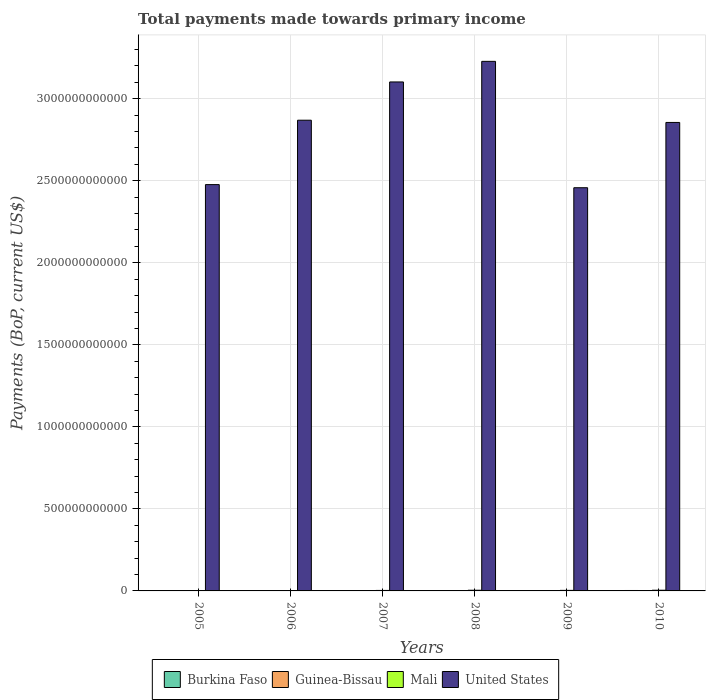How many different coloured bars are there?
Your answer should be very brief. 4. Are the number of bars per tick equal to the number of legend labels?
Ensure brevity in your answer.  Yes. What is the label of the 5th group of bars from the left?
Your answer should be very brief. 2009. What is the total payments made towards primary income in Mali in 2008?
Ensure brevity in your answer.  4.17e+09. Across all years, what is the maximum total payments made towards primary income in United States?
Keep it short and to the point. 3.23e+12. Across all years, what is the minimum total payments made towards primary income in Burkina Faso?
Keep it short and to the point. 1.45e+09. In which year was the total payments made towards primary income in United States maximum?
Ensure brevity in your answer.  2008. What is the total total payments made towards primary income in Guinea-Bissau in the graph?
Make the answer very short. 1.50e+09. What is the difference between the total payments made towards primary income in United States in 2006 and that in 2009?
Offer a very short reply. 4.11e+11. What is the difference between the total payments made towards primary income in United States in 2008 and the total payments made towards primary income in Burkina Faso in 2005?
Provide a succinct answer. 3.23e+12. What is the average total payments made towards primary income in United States per year?
Ensure brevity in your answer.  2.83e+12. In the year 2010, what is the difference between the total payments made towards primary income in United States and total payments made towards primary income in Mali?
Ensure brevity in your answer.  2.85e+12. What is the ratio of the total payments made towards primary income in Mali in 2006 to that in 2010?
Provide a succinct answer. 0.58. Is the total payments made towards primary income in Guinea-Bissau in 2006 less than that in 2009?
Provide a short and direct response. Yes. What is the difference between the highest and the second highest total payments made towards primary income in Guinea-Bissau?
Your response must be concise. 5.70e+06. What is the difference between the highest and the lowest total payments made towards primary income in Burkina Faso?
Keep it short and to the point. 1.20e+09. In how many years, is the total payments made towards primary income in United States greater than the average total payments made towards primary income in United States taken over all years?
Offer a terse response. 4. Is the sum of the total payments made towards primary income in Guinea-Bissau in 2008 and 2009 greater than the maximum total payments made towards primary income in Mali across all years?
Provide a succinct answer. No. Is it the case that in every year, the sum of the total payments made towards primary income in Mali and total payments made towards primary income in United States is greater than the sum of total payments made towards primary income in Guinea-Bissau and total payments made towards primary income in Burkina Faso?
Provide a short and direct response. Yes. What does the 3rd bar from the right in 2009 represents?
Provide a short and direct response. Guinea-Bissau. Is it the case that in every year, the sum of the total payments made towards primary income in Guinea-Bissau and total payments made towards primary income in Burkina Faso is greater than the total payments made towards primary income in Mali?
Make the answer very short. No. Are all the bars in the graph horizontal?
Offer a very short reply. No. What is the difference between two consecutive major ticks on the Y-axis?
Your response must be concise. 5.00e+11. Does the graph contain any zero values?
Your answer should be compact. No. Does the graph contain grids?
Provide a short and direct response. Yes. Where does the legend appear in the graph?
Your answer should be very brief. Bottom center. What is the title of the graph?
Make the answer very short. Total payments made towards primary income. What is the label or title of the Y-axis?
Offer a terse response. Payments (BoP, current US$). What is the Payments (BoP, current US$) of Burkina Faso in 2005?
Your answer should be very brief. 1.45e+09. What is the Payments (BoP, current US$) in Guinea-Bissau in 2005?
Your response must be concise. 1.57e+08. What is the Payments (BoP, current US$) of Mali in 2005?
Provide a short and direct response. 2.11e+09. What is the Payments (BoP, current US$) in United States in 2005?
Ensure brevity in your answer.  2.48e+12. What is the Payments (BoP, current US$) in Burkina Faso in 2006?
Keep it short and to the point. 1.51e+09. What is the Payments (BoP, current US$) of Guinea-Bissau in 2006?
Make the answer very short. 1.76e+08. What is the Payments (BoP, current US$) of Mali in 2006?
Make the answer very short. 2.48e+09. What is the Payments (BoP, current US$) in United States in 2006?
Provide a short and direct response. 2.87e+12. What is the Payments (BoP, current US$) in Burkina Faso in 2007?
Offer a very short reply. 1.77e+09. What is the Payments (BoP, current US$) of Guinea-Bissau in 2007?
Your response must be concise. 2.46e+08. What is the Payments (BoP, current US$) of Mali in 2007?
Provide a short and direct response. 2.99e+09. What is the Payments (BoP, current US$) in United States in 2007?
Give a very brief answer. 3.10e+12. What is the Payments (BoP, current US$) in Burkina Faso in 2008?
Your response must be concise. 2.44e+09. What is the Payments (BoP, current US$) in Guinea-Bissau in 2008?
Your answer should be very brief. 2.99e+08. What is the Payments (BoP, current US$) in Mali in 2008?
Offer a very short reply. 4.17e+09. What is the Payments (BoP, current US$) in United States in 2008?
Give a very brief answer. 3.23e+12. What is the Payments (BoP, current US$) of Burkina Faso in 2009?
Keep it short and to the point. 2.03e+09. What is the Payments (BoP, current US$) of Guinea-Bissau in 2009?
Ensure brevity in your answer.  3.09e+08. What is the Payments (BoP, current US$) of Mali in 2009?
Provide a short and direct response. 3.35e+09. What is the Payments (BoP, current US$) of United States in 2009?
Keep it short and to the point. 2.46e+12. What is the Payments (BoP, current US$) in Burkina Faso in 2010?
Provide a succinct answer. 2.65e+09. What is the Payments (BoP, current US$) in Guinea-Bissau in 2010?
Provide a short and direct response. 3.15e+08. What is the Payments (BoP, current US$) in Mali in 2010?
Offer a very short reply. 4.24e+09. What is the Payments (BoP, current US$) in United States in 2010?
Make the answer very short. 2.86e+12. Across all years, what is the maximum Payments (BoP, current US$) in Burkina Faso?
Offer a terse response. 2.65e+09. Across all years, what is the maximum Payments (BoP, current US$) of Guinea-Bissau?
Provide a short and direct response. 3.15e+08. Across all years, what is the maximum Payments (BoP, current US$) of Mali?
Your answer should be compact. 4.24e+09. Across all years, what is the maximum Payments (BoP, current US$) of United States?
Your answer should be compact. 3.23e+12. Across all years, what is the minimum Payments (BoP, current US$) in Burkina Faso?
Offer a very short reply. 1.45e+09. Across all years, what is the minimum Payments (BoP, current US$) in Guinea-Bissau?
Keep it short and to the point. 1.57e+08. Across all years, what is the minimum Payments (BoP, current US$) of Mali?
Your answer should be compact. 2.11e+09. Across all years, what is the minimum Payments (BoP, current US$) in United States?
Keep it short and to the point. 2.46e+12. What is the total Payments (BoP, current US$) of Burkina Faso in the graph?
Ensure brevity in your answer.  1.19e+1. What is the total Payments (BoP, current US$) in Guinea-Bissau in the graph?
Provide a succinct answer. 1.50e+09. What is the total Payments (BoP, current US$) in Mali in the graph?
Your response must be concise. 1.93e+1. What is the total Payments (BoP, current US$) of United States in the graph?
Offer a very short reply. 1.70e+13. What is the difference between the Payments (BoP, current US$) in Burkina Faso in 2005 and that in 2006?
Provide a short and direct response. -5.92e+07. What is the difference between the Payments (BoP, current US$) of Guinea-Bissau in 2005 and that in 2006?
Ensure brevity in your answer.  -1.88e+07. What is the difference between the Payments (BoP, current US$) in Mali in 2005 and that in 2006?
Make the answer very short. -3.68e+08. What is the difference between the Payments (BoP, current US$) of United States in 2005 and that in 2006?
Provide a succinct answer. -3.92e+11. What is the difference between the Payments (BoP, current US$) of Burkina Faso in 2005 and that in 2007?
Offer a terse response. -3.15e+08. What is the difference between the Payments (BoP, current US$) of Guinea-Bissau in 2005 and that in 2007?
Give a very brief answer. -8.96e+07. What is the difference between the Payments (BoP, current US$) in Mali in 2005 and that in 2007?
Offer a terse response. -8.77e+08. What is the difference between the Payments (BoP, current US$) in United States in 2005 and that in 2007?
Provide a succinct answer. -6.26e+11. What is the difference between the Payments (BoP, current US$) in Burkina Faso in 2005 and that in 2008?
Offer a terse response. -9.89e+08. What is the difference between the Payments (BoP, current US$) of Guinea-Bissau in 2005 and that in 2008?
Provide a short and direct response. -1.42e+08. What is the difference between the Payments (BoP, current US$) in Mali in 2005 and that in 2008?
Your answer should be very brief. -2.06e+09. What is the difference between the Payments (BoP, current US$) of United States in 2005 and that in 2008?
Your answer should be compact. -7.51e+11. What is the difference between the Payments (BoP, current US$) in Burkina Faso in 2005 and that in 2009?
Keep it short and to the point. -5.82e+08. What is the difference between the Payments (BoP, current US$) in Guinea-Bissau in 2005 and that in 2009?
Provide a short and direct response. -1.52e+08. What is the difference between the Payments (BoP, current US$) of Mali in 2005 and that in 2009?
Give a very brief answer. -1.24e+09. What is the difference between the Payments (BoP, current US$) of United States in 2005 and that in 2009?
Ensure brevity in your answer.  1.90e+1. What is the difference between the Payments (BoP, current US$) in Burkina Faso in 2005 and that in 2010?
Make the answer very short. -1.20e+09. What is the difference between the Payments (BoP, current US$) in Guinea-Bissau in 2005 and that in 2010?
Keep it short and to the point. -1.58e+08. What is the difference between the Payments (BoP, current US$) of Mali in 2005 and that in 2010?
Provide a short and direct response. -2.13e+09. What is the difference between the Payments (BoP, current US$) in United States in 2005 and that in 2010?
Offer a terse response. -3.79e+11. What is the difference between the Payments (BoP, current US$) of Burkina Faso in 2006 and that in 2007?
Give a very brief answer. -2.56e+08. What is the difference between the Payments (BoP, current US$) of Guinea-Bissau in 2006 and that in 2007?
Keep it short and to the point. -7.07e+07. What is the difference between the Payments (BoP, current US$) of Mali in 2006 and that in 2007?
Offer a terse response. -5.09e+08. What is the difference between the Payments (BoP, current US$) of United States in 2006 and that in 2007?
Provide a succinct answer. -2.33e+11. What is the difference between the Payments (BoP, current US$) of Burkina Faso in 2006 and that in 2008?
Ensure brevity in your answer.  -9.30e+08. What is the difference between the Payments (BoP, current US$) in Guinea-Bissau in 2006 and that in 2008?
Provide a succinct answer. -1.23e+08. What is the difference between the Payments (BoP, current US$) in Mali in 2006 and that in 2008?
Your answer should be very brief. -1.70e+09. What is the difference between the Payments (BoP, current US$) of United States in 2006 and that in 2008?
Provide a short and direct response. -3.59e+11. What is the difference between the Payments (BoP, current US$) of Burkina Faso in 2006 and that in 2009?
Provide a succinct answer. -5.23e+08. What is the difference between the Payments (BoP, current US$) in Guinea-Bissau in 2006 and that in 2009?
Provide a succinct answer. -1.33e+08. What is the difference between the Payments (BoP, current US$) in Mali in 2006 and that in 2009?
Provide a short and direct response. -8.75e+08. What is the difference between the Payments (BoP, current US$) of United States in 2006 and that in 2009?
Your response must be concise. 4.11e+11. What is the difference between the Payments (BoP, current US$) of Burkina Faso in 2006 and that in 2010?
Offer a very short reply. -1.14e+09. What is the difference between the Payments (BoP, current US$) in Guinea-Bissau in 2006 and that in 2010?
Provide a short and direct response. -1.39e+08. What is the difference between the Payments (BoP, current US$) of Mali in 2006 and that in 2010?
Offer a very short reply. -1.76e+09. What is the difference between the Payments (BoP, current US$) in United States in 2006 and that in 2010?
Offer a very short reply. 1.36e+1. What is the difference between the Payments (BoP, current US$) of Burkina Faso in 2007 and that in 2008?
Make the answer very short. -6.74e+08. What is the difference between the Payments (BoP, current US$) of Guinea-Bissau in 2007 and that in 2008?
Your response must be concise. -5.24e+07. What is the difference between the Payments (BoP, current US$) in Mali in 2007 and that in 2008?
Your answer should be very brief. -1.19e+09. What is the difference between the Payments (BoP, current US$) in United States in 2007 and that in 2008?
Provide a short and direct response. -1.26e+11. What is the difference between the Payments (BoP, current US$) of Burkina Faso in 2007 and that in 2009?
Your answer should be very brief. -2.68e+08. What is the difference between the Payments (BoP, current US$) in Guinea-Bissau in 2007 and that in 2009?
Give a very brief answer. -6.25e+07. What is the difference between the Payments (BoP, current US$) of Mali in 2007 and that in 2009?
Your answer should be compact. -3.65e+08. What is the difference between the Payments (BoP, current US$) in United States in 2007 and that in 2009?
Ensure brevity in your answer.  6.45e+11. What is the difference between the Payments (BoP, current US$) of Burkina Faso in 2007 and that in 2010?
Make the answer very short. -8.88e+08. What is the difference between the Payments (BoP, current US$) of Guinea-Bissau in 2007 and that in 2010?
Make the answer very short. -6.82e+07. What is the difference between the Payments (BoP, current US$) in Mali in 2007 and that in 2010?
Your response must be concise. -1.25e+09. What is the difference between the Payments (BoP, current US$) of United States in 2007 and that in 2010?
Provide a succinct answer. 2.47e+11. What is the difference between the Payments (BoP, current US$) of Burkina Faso in 2008 and that in 2009?
Make the answer very short. 4.07e+08. What is the difference between the Payments (BoP, current US$) in Guinea-Bissau in 2008 and that in 2009?
Make the answer very short. -1.01e+07. What is the difference between the Payments (BoP, current US$) in Mali in 2008 and that in 2009?
Offer a very short reply. 8.21e+08. What is the difference between the Payments (BoP, current US$) in United States in 2008 and that in 2009?
Your answer should be very brief. 7.70e+11. What is the difference between the Payments (BoP, current US$) in Burkina Faso in 2008 and that in 2010?
Provide a short and direct response. -2.13e+08. What is the difference between the Payments (BoP, current US$) of Guinea-Bissau in 2008 and that in 2010?
Your response must be concise. -1.58e+07. What is the difference between the Payments (BoP, current US$) of Mali in 2008 and that in 2010?
Your answer should be compact. -6.41e+07. What is the difference between the Payments (BoP, current US$) of United States in 2008 and that in 2010?
Offer a terse response. 3.72e+11. What is the difference between the Payments (BoP, current US$) of Burkina Faso in 2009 and that in 2010?
Keep it short and to the point. -6.20e+08. What is the difference between the Payments (BoP, current US$) of Guinea-Bissau in 2009 and that in 2010?
Your answer should be very brief. -5.70e+06. What is the difference between the Payments (BoP, current US$) in Mali in 2009 and that in 2010?
Offer a very short reply. -8.85e+08. What is the difference between the Payments (BoP, current US$) of United States in 2009 and that in 2010?
Provide a succinct answer. -3.98e+11. What is the difference between the Payments (BoP, current US$) in Burkina Faso in 2005 and the Payments (BoP, current US$) in Guinea-Bissau in 2006?
Make the answer very short. 1.28e+09. What is the difference between the Payments (BoP, current US$) of Burkina Faso in 2005 and the Payments (BoP, current US$) of Mali in 2006?
Ensure brevity in your answer.  -1.02e+09. What is the difference between the Payments (BoP, current US$) in Burkina Faso in 2005 and the Payments (BoP, current US$) in United States in 2006?
Offer a terse response. -2.87e+12. What is the difference between the Payments (BoP, current US$) in Guinea-Bissau in 2005 and the Payments (BoP, current US$) in Mali in 2006?
Offer a terse response. -2.32e+09. What is the difference between the Payments (BoP, current US$) of Guinea-Bissau in 2005 and the Payments (BoP, current US$) of United States in 2006?
Make the answer very short. -2.87e+12. What is the difference between the Payments (BoP, current US$) in Mali in 2005 and the Payments (BoP, current US$) in United States in 2006?
Give a very brief answer. -2.87e+12. What is the difference between the Payments (BoP, current US$) in Burkina Faso in 2005 and the Payments (BoP, current US$) in Guinea-Bissau in 2007?
Provide a short and direct response. 1.21e+09. What is the difference between the Payments (BoP, current US$) of Burkina Faso in 2005 and the Payments (BoP, current US$) of Mali in 2007?
Your answer should be very brief. -1.53e+09. What is the difference between the Payments (BoP, current US$) in Burkina Faso in 2005 and the Payments (BoP, current US$) in United States in 2007?
Provide a succinct answer. -3.10e+12. What is the difference between the Payments (BoP, current US$) of Guinea-Bissau in 2005 and the Payments (BoP, current US$) of Mali in 2007?
Provide a short and direct response. -2.83e+09. What is the difference between the Payments (BoP, current US$) of Guinea-Bissau in 2005 and the Payments (BoP, current US$) of United States in 2007?
Provide a succinct answer. -3.10e+12. What is the difference between the Payments (BoP, current US$) of Mali in 2005 and the Payments (BoP, current US$) of United States in 2007?
Make the answer very short. -3.10e+12. What is the difference between the Payments (BoP, current US$) in Burkina Faso in 2005 and the Payments (BoP, current US$) in Guinea-Bissau in 2008?
Give a very brief answer. 1.15e+09. What is the difference between the Payments (BoP, current US$) of Burkina Faso in 2005 and the Payments (BoP, current US$) of Mali in 2008?
Your answer should be very brief. -2.72e+09. What is the difference between the Payments (BoP, current US$) in Burkina Faso in 2005 and the Payments (BoP, current US$) in United States in 2008?
Your response must be concise. -3.23e+12. What is the difference between the Payments (BoP, current US$) in Guinea-Bissau in 2005 and the Payments (BoP, current US$) in Mali in 2008?
Keep it short and to the point. -4.01e+09. What is the difference between the Payments (BoP, current US$) in Guinea-Bissau in 2005 and the Payments (BoP, current US$) in United States in 2008?
Ensure brevity in your answer.  -3.23e+12. What is the difference between the Payments (BoP, current US$) in Mali in 2005 and the Payments (BoP, current US$) in United States in 2008?
Make the answer very short. -3.23e+12. What is the difference between the Payments (BoP, current US$) in Burkina Faso in 2005 and the Payments (BoP, current US$) in Guinea-Bissau in 2009?
Your answer should be compact. 1.14e+09. What is the difference between the Payments (BoP, current US$) of Burkina Faso in 2005 and the Payments (BoP, current US$) of Mali in 2009?
Ensure brevity in your answer.  -1.90e+09. What is the difference between the Payments (BoP, current US$) in Burkina Faso in 2005 and the Payments (BoP, current US$) in United States in 2009?
Offer a very short reply. -2.46e+12. What is the difference between the Payments (BoP, current US$) of Guinea-Bissau in 2005 and the Payments (BoP, current US$) of Mali in 2009?
Provide a succinct answer. -3.19e+09. What is the difference between the Payments (BoP, current US$) of Guinea-Bissau in 2005 and the Payments (BoP, current US$) of United States in 2009?
Your answer should be very brief. -2.46e+12. What is the difference between the Payments (BoP, current US$) in Mali in 2005 and the Payments (BoP, current US$) in United States in 2009?
Make the answer very short. -2.46e+12. What is the difference between the Payments (BoP, current US$) in Burkina Faso in 2005 and the Payments (BoP, current US$) in Guinea-Bissau in 2010?
Keep it short and to the point. 1.14e+09. What is the difference between the Payments (BoP, current US$) in Burkina Faso in 2005 and the Payments (BoP, current US$) in Mali in 2010?
Your answer should be very brief. -2.78e+09. What is the difference between the Payments (BoP, current US$) of Burkina Faso in 2005 and the Payments (BoP, current US$) of United States in 2010?
Offer a very short reply. -2.85e+12. What is the difference between the Payments (BoP, current US$) in Guinea-Bissau in 2005 and the Payments (BoP, current US$) in Mali in 2010?
Give a very brief answer. -4.08e+09. What is the difference between the Payments (BoP, current US$) of Guinea-Bissau in 2005 and the Payments (BoP, current US$) of United States in 2010?
Your answer should be very brief. -2.86e+12. What is the difference between the Payments (BoP, current US$) in Mali in 2005 and the Payments (BoP, current US$) in United States in 2010?
Make the answer very short. -2.85e+12. What is the difference between the Payments (BoP, current US$) of Burkina Faso in 2006 and the Payments (BoP, current US$) of Guinea-Bissau in 2007?
Your answer should be very brief. 1.26e+09. What is the difference between the Payments (BoP, current US$) in Burkina Faso in 2006 and the Payments (BoP, current US$) in Mali in 2007?
Provide a succinct answer. -1.47e+09. What is the difference between the Payments (BoP, current US$) in Burkina Faso in 2006 and the Payments (BoP, current US$) in United States in 2007?
Keep it short and to the point. -3.10e+12. What is the difference between the Payments (BoP, current US$) of Guinea-Bissau in 2006 and the Payments (BoP, current US$) of Mali in 2007?
Provide a short and direct response. -2.81e+09. What is the difference between the Payments (BoP, current US$) in Guinea-Bissau in 2006 and the Payments (BoP, current US$) in United States in 2007?
Your response must be concise. -3.10e+12. What is the difference between the Payments (BoP, current US$) in Mali in 2006 and the Payments (BoP, current US$) in United States in 2007?
Make the answer very short. -3.10e+12. What is the difference between the Payments (BoP, current US$) in Burkina Faso in 2006 and the Payments (BoP, current US$) in Guinea-Bissau in 2008?
Give a very brief answer. 1.21e+09. What is the difference between the Payments (BoP, current US$) in Burkina Faso in 2006 and the Payments (BoP, current US$) in Mali in 2008?
Your answer should be very brief. -2.66e+09. What is the difference between the Payments (BoP, current US$) in Burkina Faso in 2006 and the Payments (BoP, current US$) in United States in 2008?
Offer a terse response. -3.23e+12. What is the difference between the Payments (BoP, current US$) of Guinea-Bissau in 2006 and the Payments (BoP, current US$) of Mali in 2008?
Your answer should be very brief. -4.00e+09. What is the difference between the Payments (BoP, current US$) in Guinea-Bissau in 2006 and the Payments (BoP, current US$) in United States in 2008?
Ensure brevity in your answer.  -3.23e+12. What is the difference between the Payments (BoP, current US$) in Mali in 2006 and the Payments (BoP, current US$) in United States in 2008?
Your answer should be compact. -3.23e+12. What is the difference between the Payments (BoP, current US$) of Burkina Faso in 2006 and the Payments (BoP, current US$) of Guinea-Bissau in 2009?
Your answer should be very brief. 1.20e+09. What is the difference between the Payments (BoP, current US$) of Burkina Faso in 2006 and the Payments (BoP, current US$) of Mali in 2009?
Keep it short and to the point. -1.84e+09. What is the difference between the Payments (BoP, current US$) of Burkina Faso in 2006 and the Payments (BoP, current US$) of United States in 2009?
Your answer should be very brief. -2.46e+12. What is the difference between the Payments (BoP, current US$) in Guinea-Bissau in 2006 and the Payments (BoP, current US$) in Mali in 2009?
Provide a short and direct response. -3.18e+09. What is the difference between the Payments (BoP, current US$) of Guinea-Bissau in 2006 and the Payments (BoP, current US$) of United States in 2009?
Keep it short and to the point. -2.46e+12. What is the difference between the Payments (BoP, current US$) in Mali in 2006 and the Payments (BoP, current US$) in United States in 2009?
Offer a terse response. -2.46e+12. What is the difference between the Payments (BoP, current US$) in Burkina Faso in 2006 and the Payments (BoP, current US$) in Guinea-Bissau in 2010?
Give a very brief answer. 1.20e+09. What is the difference between the Payments (BoP, current US$) of Burkina Faso in 2006 and the Payments (BoP, current US$) of Mali in 2010?
Your answer should be compact. -2.72e+09. What is the difference between the Payments (BoP, current US$) in Burkina Faso in 2006 and the Payments (BoP, current US$) in United States in 2010?
Offer a very short reply. -2.85e+12. What is the difference between the Payments (BoP, current US$) in Guinea-Bissau in 2006 and the Payments (BoP, current US$) in Mali in 2010?
Provide a short and direct response. -4.06e+09. What is the difference between the Payments (BoP, current US$) in Guinea-Bissau in 2006 and the Payments (BoP, current US$) in United States in 2010?
Your answer should be compact. -2.86e+12. What is the difference between the Payments (BoP, current US$) in Mali in 2006 and the Payments (BoP, current US$) in United States in 2010?
Give a very brief answer. -2.85e+12. What is the difference between the Payments (BoP, current US$) in Burkina Faso in 2007 and the Payments (BoP, current US$) in Guinea-Bissau in 2008?
Offer a very short reply. 1.47e+09. What is the difference between the Payments (BoP, current US$) in Burkina Faso in 2007 and the Payments (BoP, current US$) in Mali in 2008?
Provide a short and direct response. -2.40e+09. What is the difference between the Payments (BoP, current US$) of Burkina Faso in 2007 and the Payments (BoP, current US$) of United States in 2008?
Offer a very short reply. -3.23e+12. What is the difference between the Payments (BoP, current US$) in Guinea-Bissau in 2007 and the Payments (BoP, current US$) in Mali in 2008?
Give a very brief answer. -3.92e+09. What is the difference between the Payments (BoP, current US$) in Guinea-Bissau in 2007 and the Payments (BoP, current US$) in United States in 2008?
Your response must be concise. -3.23e+12. What is the difference between the Payments (BoP, current US$) in Mali in 2007 and the Payments (BoP, current US$) in United States in 2008?
Ensure brevity in your answer.  -3.22e+12. What is the difference between the Payments (BoP, current US$) in Burkina Faso in 2007 and the Payments (BoP, current US$) in Guinea-Bissau in 2009?
Give a very brief answer. 1.46e+09. What is the difference between the Payments (BoP, current US$) of Burkina Faso in 2007 and the Payments (BoP, current US$) of Mali in 2009?
Provide a succinct answer. -1.58e+09. What is the difference between the Payments (BoP, current US$) in Burkina Faso in 2007 and the Payments (BoP, current US$) in United States in 2009?
Provide a short and direct response. -2.46e+12. What is the difference between the Payments (BoP, current US$) of Guinea-Bissau in 2007 and the Payments (BoP, current US$) of Mali in 2009?
Ensure brevity in your answer.  -3.10e+09. What is the difference between the Payments (BoP, current US$) of Guinea-Bissau in 2007 and the Payments (BoP, current US$) of United States in 2009?
Your answer should be very brief. -2.46e+12. What is the difference between the Payments (BoP, current US$) of Mali in 2007 and the Payments (BoP, current US$) of United States in 2009?
Provide a succinct answer. -2.45e+12. What is the difference between the Payments (BoP, current US$) in Burkina Faso in 2007 and the Payments (BoP, current US$) in Guinea-Bissau in 2010?
Your response must be concise. 1.45e+09. What is the difference between the Payments (BoP, current US$) of Burkina Faso in 2007 and the Payments (BoP, current US$) of Mali in 2010?
Ensure brevity in your answer.  -2.47e+09. What is the difference between the Payments (BoP, current US$) in Burkina Faso in 2007 and the Payments (BoP, current US$) in United States in 2010?
Your response must be concise. -2.85e+12. What is the difference between the Payments (BoP, current US$) of Guinea-Bissau in 2007 and the Payments (BoP, current US$) of Mali in 2010?
Offer a very short reply. -3.99e+09. What is the difference between the Payments (BoP, current US$) of Guinea-Bissau in 2007 and the Payments (BoP, current US$) of United States in 2010?
Your answer should be compact. -2.86e+12. What is the difference between the Payments (BoP, current US$) in Mali in 2007 and the Payments (BoP, current US$) in United States in 2010?
Offer a very short reply. -2.85e+12. What is the difference between the Payments (BoP, current US$) in Burkina Faso in 2008 and the Payments (BoP, current US$) in Guinea-Bissau in 2009?
Your response must be concise. 2.13e+09. What is the difference between the Payments (BoP, current US$) of Burkina Faso in 2008 and the Payments (BoP, current US$) of Mali in 2009?
Offer a terse response. -9.09e+08. What is the difference between the Payments (BoP, current US$) of Burkina Faso in 2008 and the Payments (BoP, current US$) of United States in 2009?
Your answer should be compact. -2.46e+12. What is the difference between the Payments (BoP, current US$) of Guinea-Bissau in 2008 and the Payments (BoP, current US$) of Mali in 2009?
Provide a succinct answer. -3.05e+09. What is the difference between the Payments (BoP, current US$) in Guinea-Bissau in 2008 and the Payments (BoP, current US$) in United States in 2009?
Your answer should be compact. -2.46e+12. What is the difference between the Payments (BoP, current US$) in Mali in 2008 and the Payments (BoP, current US$) in United States in 2009?
Your response must be concise. -2.45e+12. What is the difference between the Payments (BoP, current US$) in Burkina Faso in 2008 and the Payments (BoP, current US$) in Guinea-Bissau in 2010?
Offer a very short reply. 2.13e+09. What is the difference between the Payments (BoP, current US$) in Burkina Faso in 2008 and the Payments (BoP, current US$) in Mali in 2010?
Make the answer very short. -1.79e+09. What is the difference between the Payments (BoP, current US$) of Burkina Faso in 2008 and the Payments (BoP, current US$) of United States in 2010?
Provide a succinct answer. -2.85e+12. What is the difference between the Payments (BoP, current US$) in Guinea-Bissau in 2008 and the Payments (BoP, current US$) in Mali in 2010?
Provide a succinct answer. -3.94e+09. What is the difference between the Payments (BoP, current US$) in Guinea-Bissau in 2008 and the Payments (BoP, current US$) in United States in 2010?
Make the answer very short. -2.86e+12. What is the difference between the Payments (BoP, current US$) in Mali in 2008 and the Payments (BoP, current US$) in United States in 2010?
Your response must be concise. -2.85e+12. What is the difference between the Payments (BoP, current US$) in Burkina Faso in 2009 and the Payments (BoP, current US$) in Guinea-Bissau in 2010?
Offer a very short reply. 1.72e+09. What is the difference between the Payments (BoP, current US$) in Burkina Faso in 2009 and the Payments (BoP, current US$) in Mali in 2010?
Provide a short and direct response. -2.20e+09. What is the difference between the Payments (BoP, current US$) of Burkina Faso in 2009 and the Payments (BoP, current US$) of United States in 2010?
Offer a terse response. -2.85e+12. What is the difference between the Payments (BoP, current US$) in Guinea-Bissau in 2009 and the Payments (BoP, current US$) in Mali in 2010?
Your answer should be compact. -3.93e+09. What is the difference between the Payments (BoP, current US$) in Guinea-Bissau in 2009 and the Payments (BoP, current US$) in United States in 2010?
Make the answer very short. -2.86e+12. What is the difference between the Payments (BoP, current US$) in Mali in 2009 and the Payments (BoP, current US$) in United States in 2010?
Provide a short and direct response. -2.85e+12. What is the average Payments (BoP, current US$) of Burkina Faso per year?
Ensure brevity in your answer.  1.98e+09. What is the average Payments (BoP, current US$) in Guinea-Bissau per year?
Make the answer very short. 2.50e+08. What is the average Payments (BoP, current US$) in Mali per year?
Offer a very short reply. 3.22e+09. What is the average Payments (BoP, current US$) in United States per year?
Make the answer very short. 2.83e+12. In the year 2005, what is the difference between the Payments (BoP, current US$) of Burkina Faso and Payments (BoP, current US$) of Guinea-Bissau?
Your answer should be very brief. 1.30e+09. In the year 2005, what is the difference between the Payments (BoP, current US$) of Burkina Faso and Payments (BoP, current US$) of Mali?
Make the answer very short. -6.56e+08. In the year 2005, what is the difference between the Payments (BoP, current US$) of Burkina Faso and Payments (BoP, current US$) of United States?
Offer a terse response. -2.48e+12. In the year 2005, what is the difference between the Payments (BoP, current US$) of Guinea-Bissau and Payments (BoP, current US$) of Mali?
Provide a succinct answer. -1.95e+09. In the year 2005, what is the difference between the Payments (BoP, current US$) of Guinea-Bissau and Payments (BoP, current US$) of United States?
Provide a succinct answer. -2.48e+12. In the year 2005, what is the difference between the Payments (BoP, current US$) of Mali and Payments (BoP, current US$) of United States?
Offer a terse response. -2.47e+12. In the year 2006, what is the difference between the Payments (BoP, current US$) in Burkina Faso and Payments (BoP, current US$) in Guinea-Bissau?
Make the answer very short. 1.34e+09. In the year 2006, what is the difference between the Payments (BoP, current US$) of Burkina Faso and Payments (BoP, current US$) of Mali?
Your answer should be compact. -9.65e+08. In the year 2006, what is the difference between the Payments (BoP, current US$) of Burkina Faso and Payments (BoP, current US$) of United States?
Ensure brevity in your answer.  -2.87e+12. In the year 2006, what is the difference between the Payments (BoP, current US$) of Guinea-Bissau and Payments (BoP, current US$) of Mali?
Give a very brief answer. -2.30e+09. In the year 2006, what is the difference between the Payments (BoP, current US$) in Guinea-Bissau and Payments (BoP, current US$) in United States?
Your response must be concise. -2.87e+12. In the year 2006, what is the difference between the Payments (BoP, current US$) of Mali and Payments (BoP, current US$) of United States?
Ensure brevity in your answer.  -2.87e+12. In the year 2007, what is the difference between the Payments (BoP, current US$) in Burkina Faso and Payments (BoP, current US$) in Guinea-Bissau?
Give a very brief answer. 1.52e+09. In the year 2007, what is the difference between the Payments (BoP, current US$) of Burkina Faso and Payments (BoP, current US$) of Mali?
Provide a short and direct response. -1.22e+09. In the year 2007, what is the difference between the Payments (BoP, current US$) in Burkina Faso and Payments (BoP, current US$) in United States?
Provide a succinct answer. -3.10e+12. In the year 2007, what is the difference between the Payments (BoP, current US$) in Guinea-Bissau and Payments (BoP, current US$) in Mali?
Keep it short and to the point. -2.74e+09. In the year 2007, what is the difference between the Payments (BoP, current US$) in Guinea-Bissau and Payments (BoP, current US$) in United States?
Offer a terse response. -3.10e+12. In the year 2007, what is the difference between the Payments (BoP, current US$) in Mali and Payments (BoP, current US$) in United States?
Make the answer very short. -3.10e+12. In the year 2008, what is the difference between the Payments (BoP, current US$) in Burkina Faso and Payments (BoP, current US$) in Guinea-Bissau?
Provide a short and direct response. 2.14e+09. In the year 2008, what is the difference between the Payments (BoP, current US$) in Burkina Faso and Payments (BoP, current US$) in Mali?
Provide a succinct answer. -1.73e+09. In the year 2008, what is the difference between the Payments (BoP, current US$) in Burkina Faso and Payments (BoP, current US$) in United States?
Provide a short and direct response. -3.23e+12. In the year 2008, what is the difference between the Payments (BoP, current US$) of Guinea-Bissau and Payments (BoP, current US$) of Mali?
Your answer should be very brief. -3.87e+09. In the year 2008, what is the difference between the Payments (BoP, current US$) of Guinea-Bissau and Payments (BoP, current US$) of United States?
Your response must be concise. -3.23e+12. In the year 2008, what is the difference between the Payments (BoP, current US$) of Mali and Payments (BoP, current US$) of United States?
Your answer should be very brief. -3.22e+12. In the year 2009, what is the difference between the Payments (BoP, current US$) in Burkina Faso and Payments (BoP, current US$) in Guinea-Bissau?
Provide a short and direct response. 1.73e+09. In the year 2009, what is the difference between the Payments (BoP, current US$) in Burkina Faso and Payments (BoP, current US$) in Mali?
Give a very brief answer. -1.32e+09. In the year 2009, what is the difference between the Payments (BoP, current US$) in Burkina Faso and Payments (BoP, current US$) in United States?
Give a very brief answer. -2.46e+12. In the year 2009, what is the difference between the Payments (BoP, current US$) of Guinea-Bissau and Payments (BoP, current US$) of Mali?
Offer a very short reply. -3.04e+09. In the year 2009, what is the difference between the Payments (BoP, current US$) of Guinea-Bissau and Payments (BoP, current US$) of United States?
Your answer should be compact. -2.46e+12. In the year 2009, what is the difference between the Payments (BoP, current US$) of Mali and Payments (BoP, current US$) of United States?
Make the answer very short. -2.45e+12. In the year 2010, what is the difference between the Payments (BoP, current US$) of Burkina Faso and Payments (BoP, current US$) of Guinea-Bissau?
Your answer should be compact. 2.34e+09. In the year 2010, what is the difference between the Payments (BoP, current US$) of Burkina Faso and Payments (BoP, current US$) of Mali?
Offer a terse response. -1.58e+09. In the year 2010, what is the difference between the Payments (BoP, current US$) of Burkina Faso and Payments (BoP, current US$) of United States?
Keep it short and to the point. -2.85e+12. In the year 2010, what is the difference between the Payments (BoP, current US$) in Guinea-Bissau and Payments (BoP, current US$) in Mali?
Your answer should be very brief. -3.92e+09. In the year 2010, what is the difference between the Payments (BoP, current US$) in Guinea-Bissau and Payments (BoP, current US$) in United States?
Keep it short and to the point. -2.86e+12. In the year 2010, what is the difference between the Payments (BoP, current US$) in Mali and Payments (BoP, current US$) in United States?
Make the answer very short. -2.85e+12. What is the ratio of the Payments (BoP, current US$) of Burkina Faso in 2005 to that in 2006?
Provide a short and direct response. 0.96. What is the ratio of the Payments (BoP, current US$) in Guinea-Bissau in 2005 to that in 2006?
Provide a short and direct response. 0.89. What is the ratio of the Payments (BoP, current US$) of Mali in 2005 to that in 2006?
Your answer should be compact. 0.85. What is the ratio of the Payments (BoP, current US$) in United States in 2005 to that in 2006?
Offer a terse response. 0.86. What is the ratio of the Payments (BoP, current US$) of Burkina Faso in 2005 to that in 2007?
Your response must be concise. 0.82. What is the ratio of the Payments (BoP, current US$) in Guinea-Bissau in 2005 to that in 2007?
Give a very brief answer. 0.64. What is the ratio of the Payments (BoP, current US$) in Mali in 2005 to that in 2007?
Keep it short and to the point. 0.71. What is the ratio of the Payments (BoP, current US$) of United States in 2005 to that in 2007?
Provide a succinct answer. 0.8. What is the ratio of the Payments (BoP, current US$) in Burkina Faso in 2005 to that in 2008?
Give a very brief answer. 0.59. What is the ratio of the Payments (BoP, current US$) in Guinea-Bissau in 2005 to that in 2008?
Keep it short and to the point. 0.53. What is the ratio of the Payments (BoP, current US$) of Mali in 2005 to that in 2008?
Your response must be concise. 0.51. What is the ratio of the Payments (BoP, current US$) in United States in 2005 to that in 2008?
Make the answer very short. 0.77. What is the ratio of the Payments (BoP, current US$) in Burkina Faso in 2005 to that in 2009?
Your answer should be compact. 0.71. What is the ratio of the Payments (BoP, current US$) of Guinea-Bissau in 2005 to that in 2009?
Your response must be concise. 0.51. What is the ratio of the Payments (BoP, current US$) in Mali in 2005 to that in 2009?
Make the answer very short. 0.63. What is the ratio of the Payments (BoP, current US$) in United States in 2005 to that in 2009?
Provide a succinct answer. 1.01. What is the ratio of the Payments (BoP, current US$) in Burkina Faso in 2005 to that in 2010?
Keep it short and to the point. 0.55. What is the ratio of the Payments (BoP, current US$) of Guinea-Bissau in 2005 to that in 2010?
Your answer should be compact. 0.5. What is the ratio of the Payments (BoP, current US$) in Mali in 2005 to that in 2010?
Ensure brevity in your answer.  0.5. What is the ratio of the Payments (BoP, current US$) in United States in 2005 to that in 2010?
Your answer should be very brief. 0.87. What is the ratio of the Payments (BoP, current US$) of Burkina Faso in 2006 to that in 2007?
Your response must be concise. 0.86. What is the ratio of the Payments (BoP, current US$) of Guinea-Bissau in 2006 to that in 2007?
Offer a terse response. 0.71. What is the ratio of the Payments (BoP, current US$) in Mali in 2006 to that in 2007?
Provide a succinct answer. 0.83. What is the ratio of the Payments (BoP, current US$) in United States in 2006 to that in 2007?
Make the answer very short. 0.92. What is the ratio of the Payments (BoP, current US$) of Burkina Faso in 2006 to that in 2008?
Your answer should be very brief. 0.62. What is the ratio of the Payments (BoP, current US$) in Guinea-Bissau in 2006 to that in 2008?
Your answer should be very brief. 0.59. What is the ratio of the Payments (BoP, current US$) of Mali in 2006 to that in 2008?
Keep it short and to the point. 0.59. What is the ratio of the Payments (BoP, current US$) of United States in 2006 to that in 2008?
Offer a terse response. 0.89. What is the ratio of the Payments (BoP, current US$) of Burkina Faso in 2006 to that in 2009?
Ensure brevity in your answer.  0.74. What is the ratio of the Payments (BoP, current US$) in Guinea-Bissau in 2006 to that in 2009?
Offer a very short reply. 0.57. What is the ratio of the Payments (BoP, current US$) of Mali in 2006 to that in 2009?
Give a very brief answer. 0.74. What is the ratio of the Payments (BoP, current US$) in United States in 2006 to that in 2009?
Provide a short and direct response. 1.17. What is the ratio of the Payments (BoP, current US$) of Burkina Faso in 2006 to that in 2010?
Your answer should be compact. 0.57. What is the ratio of the Payments (BoP, current US$) in Guinea-Bissau in 2006 to that in 2010?
Offer a terse response. 0.56. What is the ratio of the Payments (BoP, current US$) of Mali in 2006 to that in 2010?
Keep it short and to the point. 0.58. What is the ratio of the Payments (BoP, current US$) of United States in 2006 to that in 2010?
Provide a succinct answer. 1. What is the ratio of the Payments (BoP, current US$) in Burkina Faso in 2007 to that in 2008?
Your response must be concise. 0.72. What is the ratio of the Payments (BoP, current US$) in Guinea-Bissau in 2007 to that in 2008?
Offer a very short reply. 0.82. What is the ratio of the Payments (BoP, current US$) of Mali in 2007 to that in 2008?
Your answer should be compact. 0.72. What is the ratio of the Payments (BoP, current US$) in United States in 2007 to that in 2008?
Your answer should be very brief. 0.96. What is the ratio of the Payments (BoP, current US$) of Burkina Faso in 2007 to that in 2009?
Provide a succinct answer. 0.87. What is the ratio of the Payments (BoP, current US$) of Guinea-Bissau in 2007 to that in 2009?
Offer a terse response. 0.8. What is the ratio of the Payments (BoP, current US$) in Mali in 2007 to that in 2009?
Your answer should be very brief. 0.89. What is the ratio of the Payments (BoP, current US$) in United States in 2007 to that in 2009?
Provide a short and direct response. 1.26. What is the ratio of the Payments (BoP, current US$) of Burkina Faso in 2007 to that in 2010?
Offer a very short reply. 0.67. What is the ratio of the Payments (BoP, current US$) of Guinea-Bissau in 2007 to that in 2010?
Offer a very short reply. 0.78. What is the ratio of the Payments (BoP, current US$) in Mali in 2007 to that in 2010?
Your answer should be very brief. 0.7. What is the ratio of the Payments (BoP, current US$) of United States in 2007 to that in 2010?
Your answer should be very brief. 1.09. What is the ratio of the Payments (BoP, current US$) in Guinea-Bissau in 2008 to that in 2009?
Your answer should be compact. 0.97. What is the ratio of the Payments (BoP, current US$) in Mali in 2008 to that in 2009?
Make the answer very short. 1.24. What is the ratio of the Payments (BoP, current US$) in United States in 2008 to that in 2009?
Offer a very short reply. 1.31. What is the ratio of the Payments (BoP, current US$) in Burkina Faso in 2008 to that in 2010?
Give a very brief answer. 0.92. What is the ratio of the Payments (BoP, current US$) in Guinea-Bissau in 2008 to that in 2010?
Ensure brevity in your answer.  0.95. What is the ratio of the Payments (BoP, current US$) of Mali in 2008 to that in 2010?
Your answer should be very brief. 0.98. What is the ratio of the Payments (BoP, current US$) in United States in 2008 to that in 2010?
Your answer should be compact. 1.13. What is the ratio of the Payments (BoP, current US$) of Burkina Faso in 2009 to that in 2010?
Ensure brevity in your answer.  0.77. What is the ratio of the Payments (BoP, current US$) of Guinea-Bissau in 2009 to that in 2010?
Your answer should be very brief. 0.98. What is the ratio of the Payments (BoP, current US$) of Mali in 2009 to that in 2010?
Your answer should be compact. 0.79. What is the ratio of the Payments (BoP, current US$) of United States in 2009 to that in 2010?
Make the answer very short. 0.86. What is the difference between the highest and the second highest Payments (BoP, current US$) in Burkina Faso?
Keep it short and to the point. 2.13e+08. What is the difference between the highest and the second highest Payments (BoP, current US$) of Guinea-Bissau?
Make the answer very short. 5.70e+06. What is the difference between the highest and the second highest Payments (BoP, current US$) in Mali?
Give a very brief answer. 6.41e+07. What is the difference between the highest and the second highest Payments (BoP, current US$) of United States?
Provide a succinct answer. 1.26e+11. What is the difference between the highest and the lowest Payments (BoP, current US$) in Burkina Faso?
Provide a short and direct response. 1.20e+09. What is the difference between the highest and the lowest Payments (BoP, current US$) of Guinea-Bissau?
Offer a terse response. 1.58e+08. What is the difference between the highest and the lowest Payments (BoP, current US$) in Mali?
Provide a short and direct response. 2.13e+09. What is the difference between the highest and the lowest Payments (BoP, current US$) of United States?
Provide a succinct answer. 7.70e+11. 